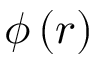Convert formula to latex. <formula><loc_0><loc_0><loc_500><loc_500>\phi \left ( r \right )</formula> 